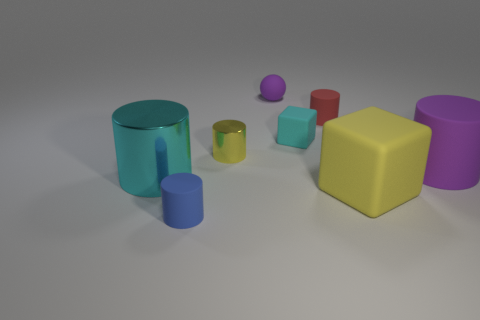Subtract all cyan cylinders. How many cylinders are left? 4 Subtract all large shiny cylinders. How many cylinders are left? 4 Add 1 large matte balls. How many objects exist? 9 Subtract all yellow cylinders. Subtract all blue spheres. How many cylinders are left? 4 Subtract all cubes. How many objects are left? 6 Add 5 large cyan metal cylinders. How many large cyan metal cylinders are left? 6 Add 6 tiny red metallic things. How many tiny red metallic things exist? 6 Subtract 1 yellow blocks. How many objects are left? 7 Subtract all tiny things. Subtract all small blue cylinders. How many objects are left? 2 